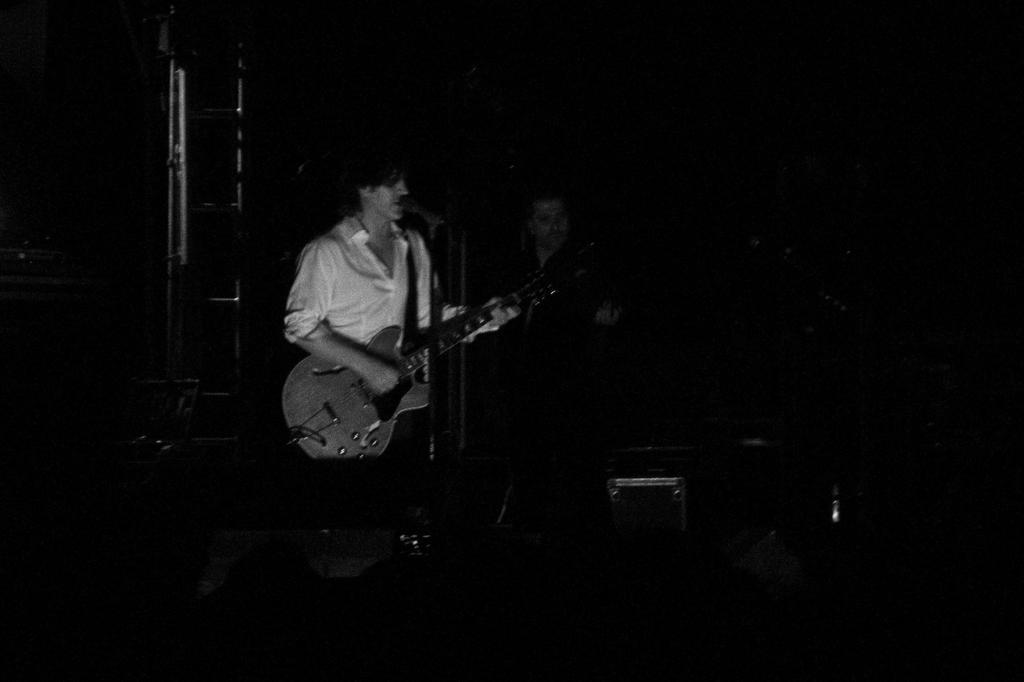Describe this image in one or two sentences. The 2 persons are standing. They are playing a musical instruments. We can see in the background ladder. 